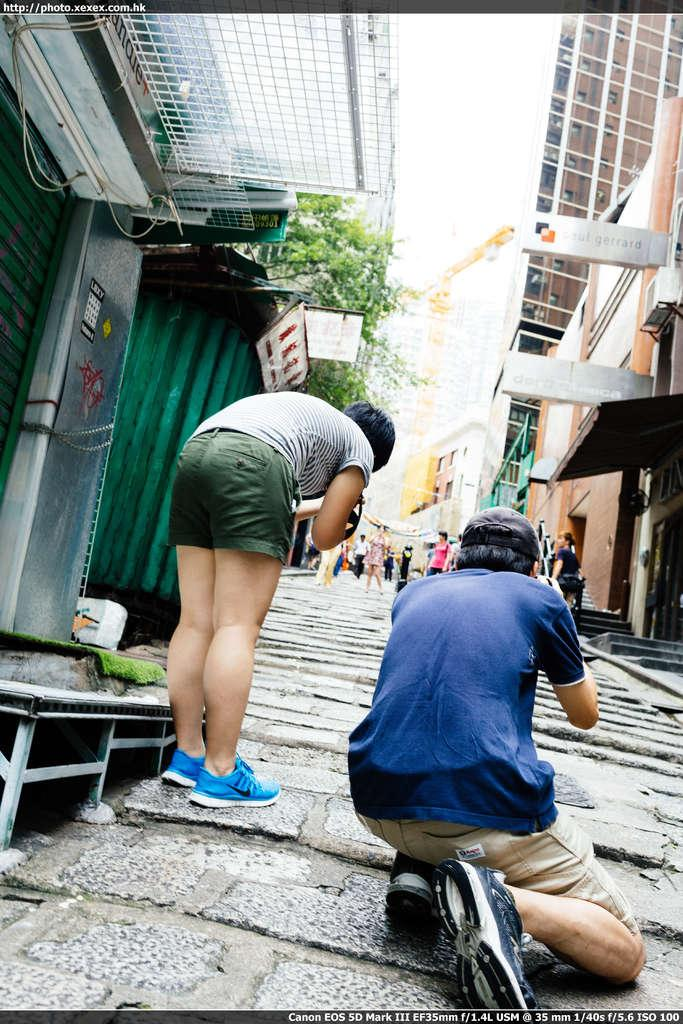How many people are present in the image? There are two persons in the image. What type of structures can be seen in the image? There are houses in the image. What other objects are visible in the image? There are boards and trees in the image. Can you describe the group of people in the image? There is a group of people in the image. What is visible in the background of the image? The sky is visible in the background of the image. Are there any visible marks on the image itself? Yes, there are watermarks on the image. How does the image show an increase in tax for the night? The image does not show any information about taxes or the night; it primarily features two persons, houses, boards, trees, a group of people, and the sky in the background. 